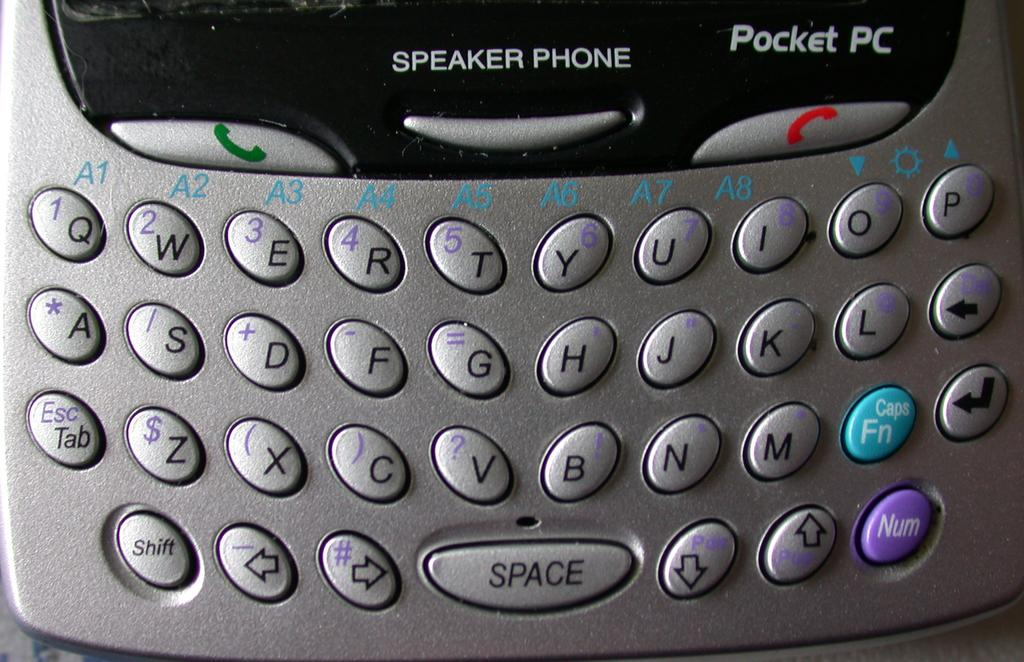<image>
Present a compact description of the photo's key features. A pocket PC phone with a QWERTY keyboard. 